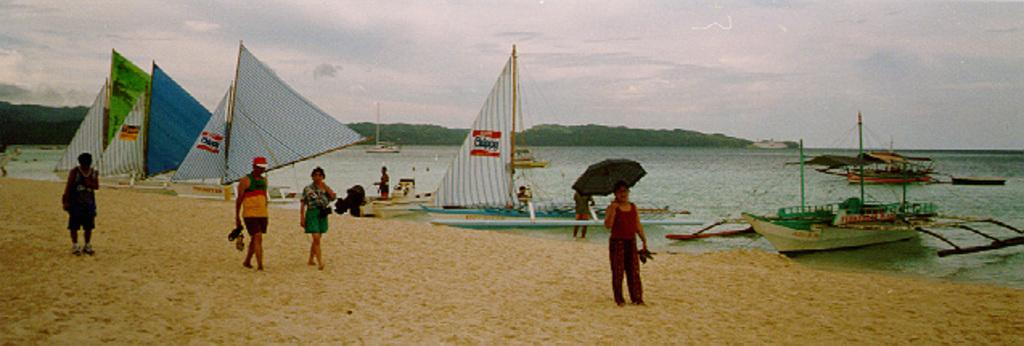How many people are in the image? There are people in the image, but the exact number is not specified. What are some people doing in the image? Some people are holding umbrellas in the image. What can be seen in the background of the image? In the background of the image, there are boats, water, and mountains. How would you describe the sky in the image? The sky in the image is a combination of white and blue colors. What type of sound can be heard coming from the line in the image? There is no line or sound present in the image. 